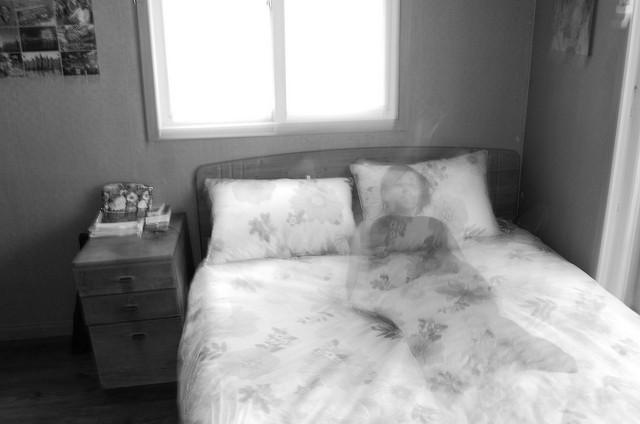Is the woman a ghost?
Answer briefly. Yes. What color is the sheets?
Give a very brief answer. White. Is it day or night time?
Write a very short answer. Day. 